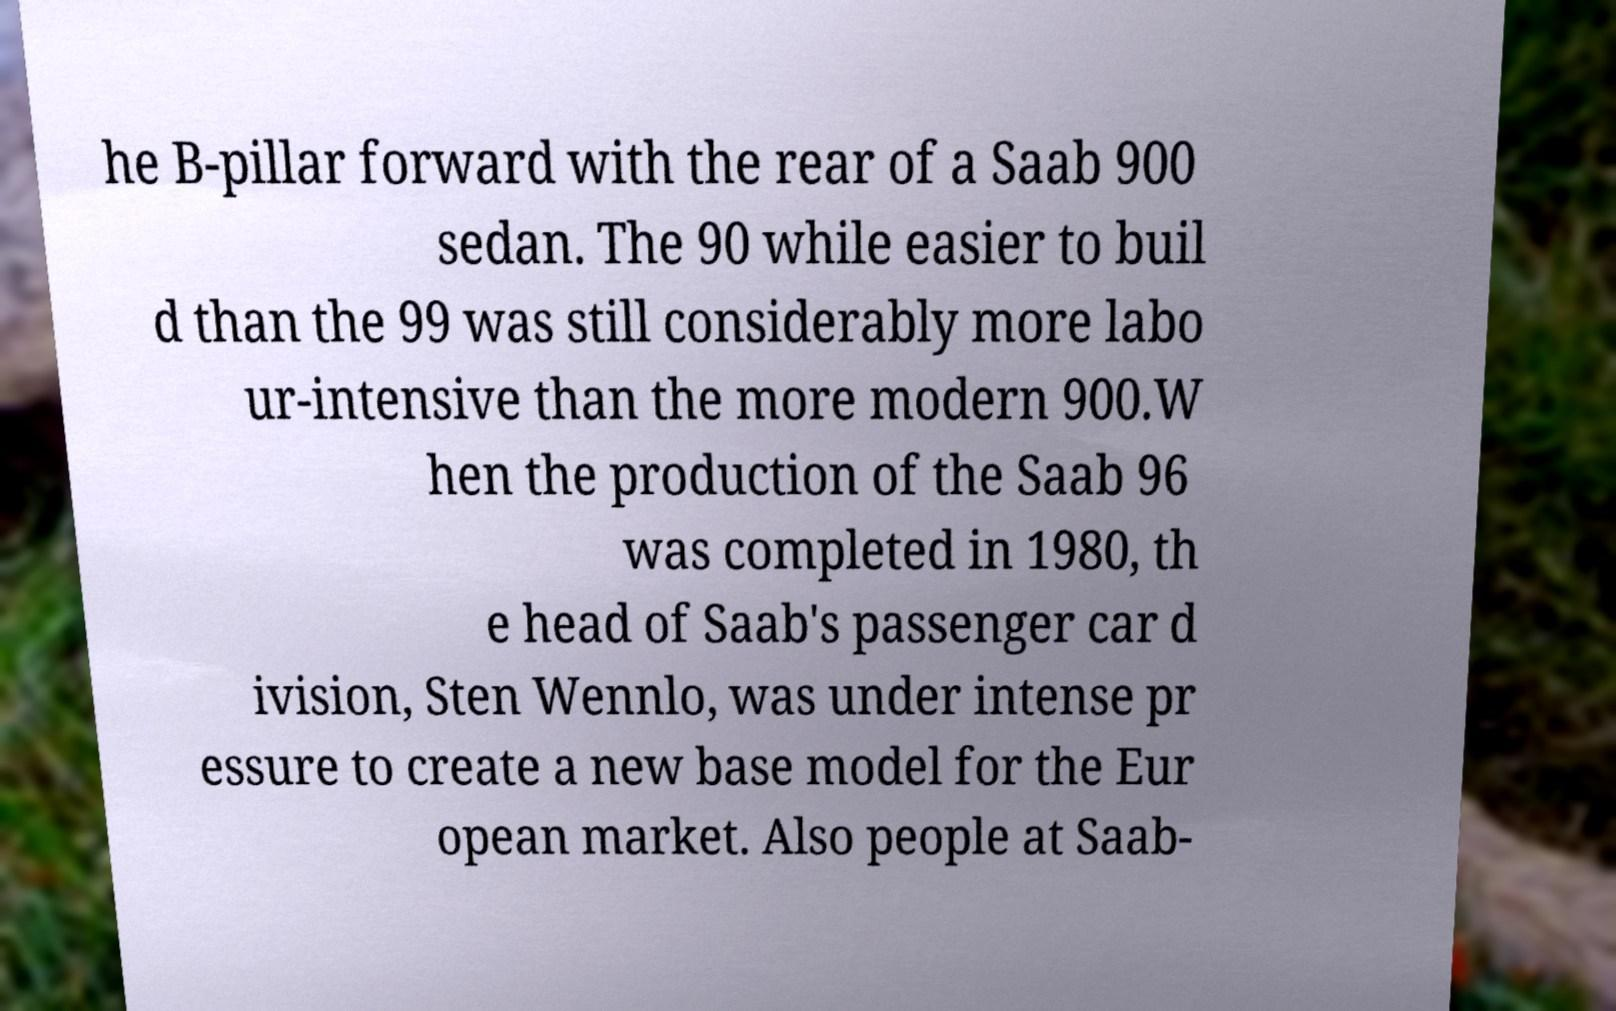Please read and relay the text visible in this image. What does it say? he B-pillar forward with the rear of a Saab 900 sedan. The 90 while easier to buil d than the 99 was still considerably more labo ur-intensive than the more modern 900.W hen the production of the Saab 96 was completed in 1980, th e head of Saab's passenger car d ivision, Sten Wennlo, was under intense pr essure to create a new base model for the Eur opean market. Also people at Saab- 